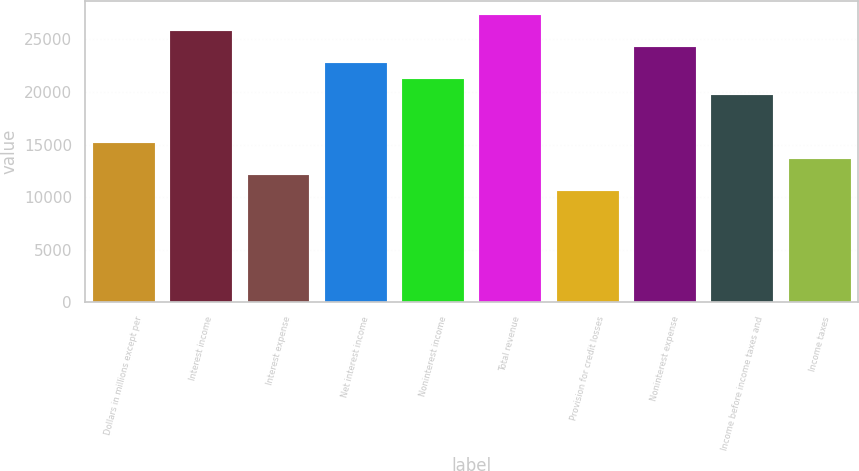Convert chart to OTSL. <chart><loc_0><loc_0><loc_500><loc_500><bar_chart><fcel>Dollars in millions except per<fcel>Interest income<fcel>Interest expense<fcel>Net interest income<fcel>Noninterest income<fcel>Total revenue<fcel>Provision for credit losses<fcel>Noninterest expense<fcel>Income before income taxes and<fcel>Income taxes<nl><fcel>15162<fcel>25774<fcel>12130<fcel>22742<fcel>21226<fcel>27289.9<fcel>10614<fcel>24258<fcel>19710<fcel>13646<nl></chart> 